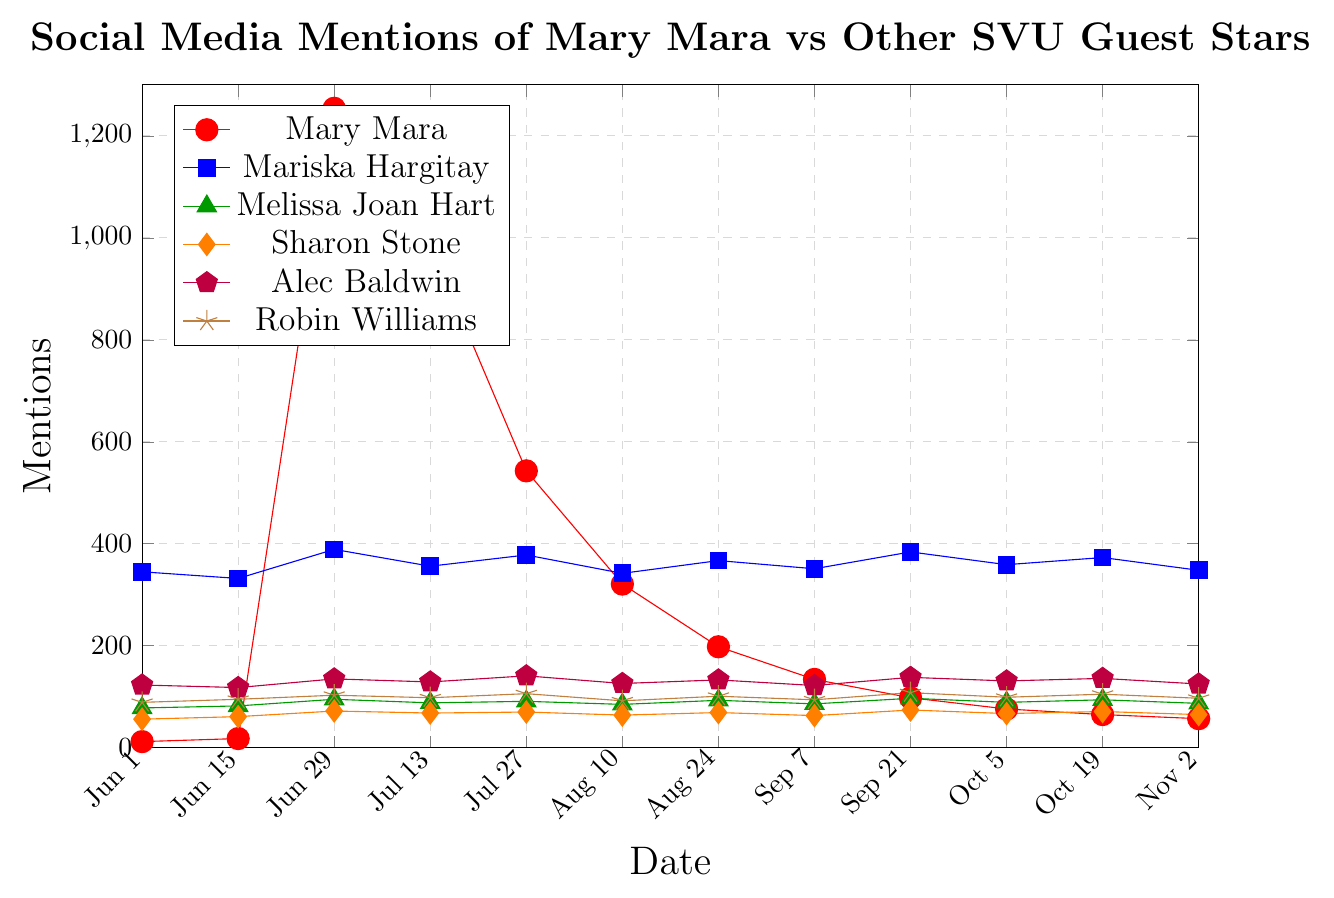What is the peak value for Mary Mara's social media mentions? Mary Mara's peak value can be found by looking for the highest point in her red line. The highest value occurs on June 29th, with 1254 mentions.
Answer: 1254 Is there any guest star with consistently higher mentions than Mary Mara after her peak on June 29th? After June 29th, Mary Mara's mentions drop. We can compare her mentions with those of other guest stars. Mariska Hargitay has consistently higher mentions after this date.
Answer: Yes, Mariska Hargitay What is the difference in social media mentions between Mary Mara and Mariska Hargitay on July 13th? On July 13th, Mary Mara has 987 mentions, and Mariska Hargitay has 356 mentions. The difference is calculated by subtracting Mariska's mentions from Mary Mara's: 987 - 356 = 631.
Answer: 631 How many dates did Robin Williams have more mentions than Alec Baldwin? By examining the graph, Robin Williams' mentions surpass Alec Baldwin's on three dates: June 15th, July 13th, and October 19th.
Answer: Three dates Calculate the average number of mentions of Sharon Stone across all dates. Summing up Sharon Stone's mentions across all dates gives: 56 + 61 + 72 + 68 + 70 + 64 + 69 + 63 + 74 + 67 + 71 + 65 = 800. There are 12 dates, so we divide the total by 12: 800 / 12 ≈ 66.67.
Answer: 66.67 Between June 29th and July 13th, did any guest star other than Mary Mara show a significant increase in mentions? Comparing the values on June 29th and July 13th, no other guest star shows a significant increase in mentions during this period.
Answer: No Which guest star had a mention count that remained closest to the same throughout the observed period? By observing the stability in the lines, Melissa Joan Hart's mentions show the least variation, staying relatively close to the same values.
Answer: Melissa Joan Hart When did Mariska Hargitay have her highest number of mentions, and what was it? Mariska Hargitay's highest number of mentions is observed on September 21st, with a value of 384.
Answer: September 21st, 384 Which guest star's mentions decreased the most sharply after a peak? Mary Mara's mentions decreased the most sharply after her peak on June 29th (1254) by the next date, July 13th (987), marking a significant drop.
Answer: Mary Mara On which date did Alec Baldwin's mentions peak, and how many mentions were there? Alec Baldwin's mentions peaked on October 19th, with 141 mentions.
Answer: October 19th, 141 